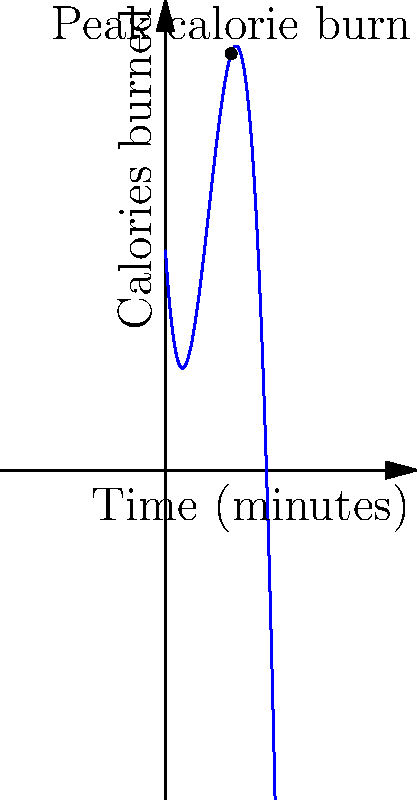The graph represents the calorie burn rate during a 10-minute high-intensity interval training (HIIT) workout. The function modeling this calorie burn is given by $f(x) = -0.5x^3 + 6x^2 - 15x + 20$, where $x$ is time in minutes and $f(x)$ is calories burned per minute. At what point in the workout does the maximum calorie burn rate occur, and what is that rate? To find the maximum calorie burn rate, we need to follow these steps:

1) The maximum point on a polynomial function occurs where its first derivative equals zero. Let's find the derivative of $f(x)$:

   $f'(x) = -1.5x^2 + 12x - 15$

2) Set $f'(x) = 0$ and solve for $x$:

   $-1.5x^2 + 12x - 15 = 0$

3) This is a quadratic equation. We can solve it using the quadratic formula:
   $x = \frac{-b \pm \sqrt{b^2 - 4ac}}{2a}$

   Where $a = -1.5$, $b = 12$, and $c = -15$

4) Plugging in these values:

   $x = \frac{-12 \pm \sqrt{12^2 - 4(-1.5)(-15)}}{2(-1.5)}$
   $= \frac{-12 \pm \sqrt{144 - 90}}{-3}$
   $= \frac{-12 \pm \sqrt{54}}{-3}$
   $= \frac{-12 \pm 3\sqrt{6}}{-3}$

5) This gives us two solutions:
   $x_1 = 6 + \sqrt{6} \approx 8.45$
   $x_2 = 6 - \sqrt{6} \approx 3.55$

6) Since we're looking at a 10-minute workout, $x_2 = 6 - \sqrt{6} \approx 3.55$ minutes is the relevant solution.

7) To find the maximum rate, we plug this x-value back into our original function:

   $f(6 - \sqrt{6}) = -0.5(6 - \sqrt{6})^3 + 6(6 - \sqrt{6})^2 - 15(6 - \sqrt{6}) + 20 \approx 38$ calories/minute

Therefore, the maximum calorie burn rate occurs at approximately 3.55 minutes into the workout, with a rate of about 38 calories per minute.
Answer: At $x \approx 3.55$ minutes, maximum rate $\approx 38$ calories/minute 